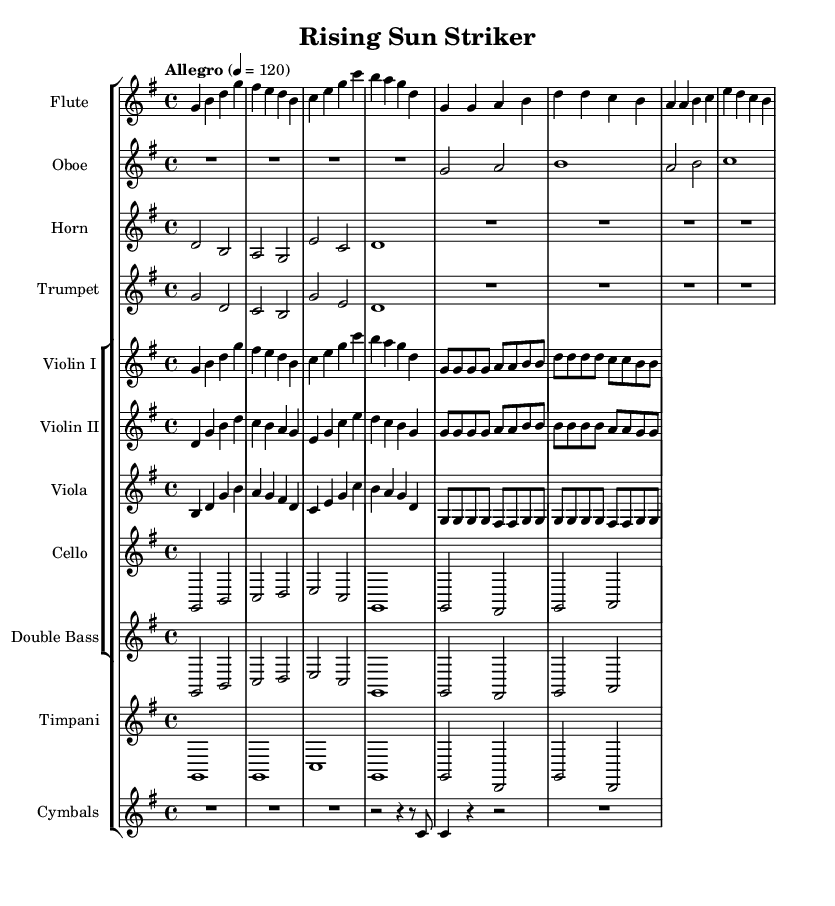What is the key signature of this music? The key signature shows one sharp, indicating it is in G major.
Answer: G major What is the time signature of this music? The time signature is represented at the beginning of the staff as 4/4, meaning there are four beats in a measure.
Answer: 4/4 What is the tempo marking in this piece? The tempo marking is "Allegro", which indicates a fast tempo typically around 120 beats per minute.
Answer: Allegro Which instruments are featured in this score? The score includes Flute, Oboe, Horn, Trumpet, Violin I, Violin II, Viola, Cello, Double Bass, Timpani, and Cymbals, showcasing a full orchestral arrangement.
Answer: Flute, Oboe, Horn, Trumpet, Violin I, Violin II, Viola, Cello, Double Bass, Timpani, Cymbals What instruments play the intro section? The intro section is presented by Flute, Horn, Trumpet, Violin I, Violin II, Viola, Cello, Double Bass, Timpani, and Cymbals, which indicates a broad orchestral introduction.
Answer: Flute, Horn, Trumpet, Violin I, Violin II, Viola, Cello, Double Bass, Timpani, Cymbals During the verse section, which instrument has a repeated melody? The Flute plays a repeated melody throughout the verse section, evident in the written notes being similar.
Answer: Flute How many measures are in the provided excerpt? The provided excerpt consists of a total of 16 measures, comprised of both the intro and verse sections.
Answer: 16 measures 